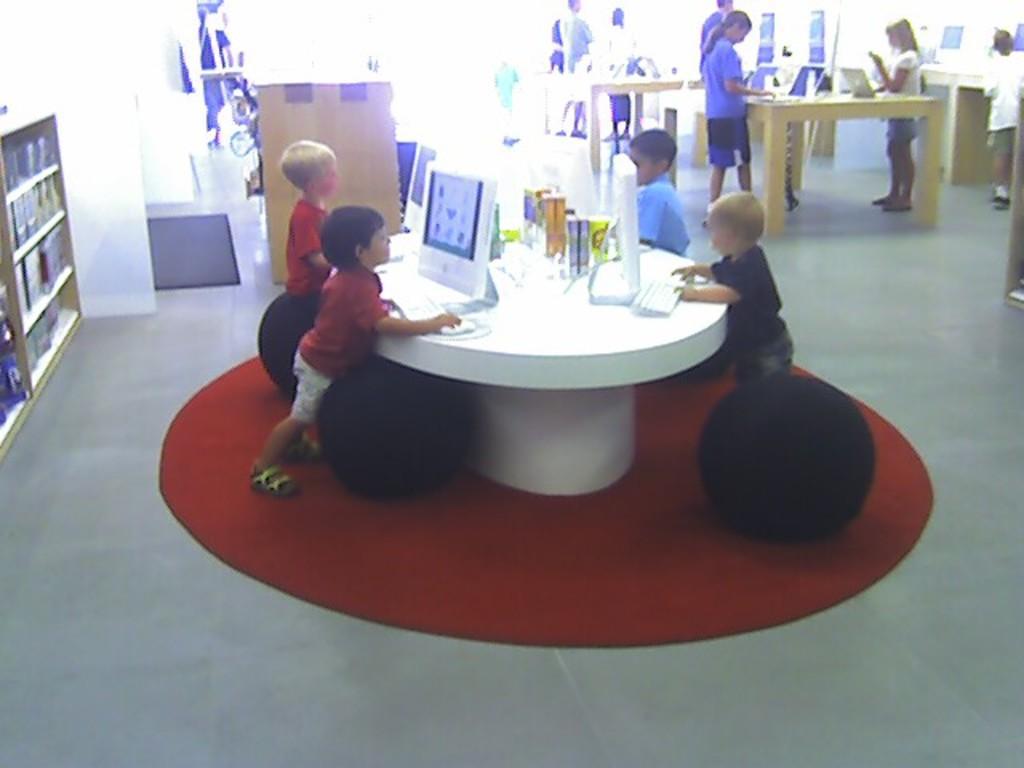Describe this image in one or two sentences. In this image few kids are standing near the table having few monitors , keyboards, bottles and few objects on it. Left side there is a rack having few books in it. Right top there are few persons standing near the table having few laptops on it. Behind the kid there are few objects are on the floor. 